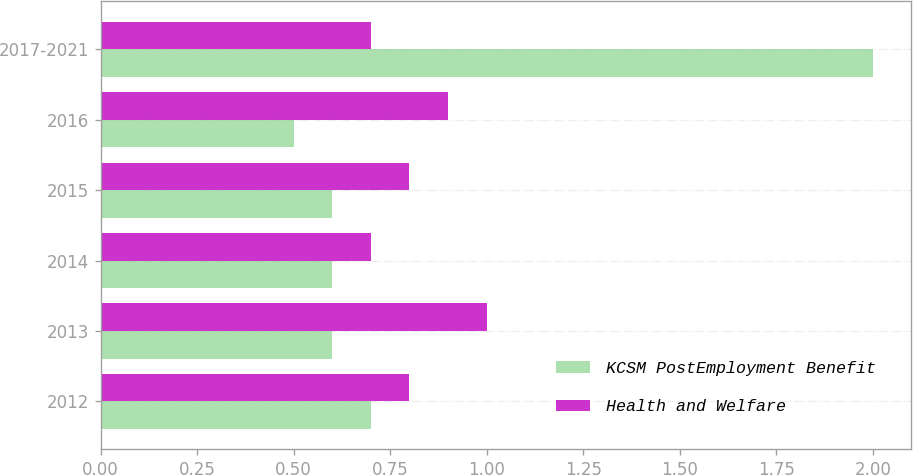Convert chart to OTSL. <chart><loc_0><loc_0><loc_500><loc_500><stacked_bar_chart><ecel><fcel>2012<fcel>2013<fcel>2014<fcel>2015<fcel>2016<fcel>2017-2021<nl><fcel>KCSM PostEmployment Benefit<fcel>0.7<fcel>0.6<fcel>0.6<fcel>0.6<fcel>0.5<fcel>2<nl><fcel>Health and Welfare<fcel>0.8<fcel>1<fcel>0.7<fcel>0.8<fcel>0.9<fcel>0.7<nl></chart> 